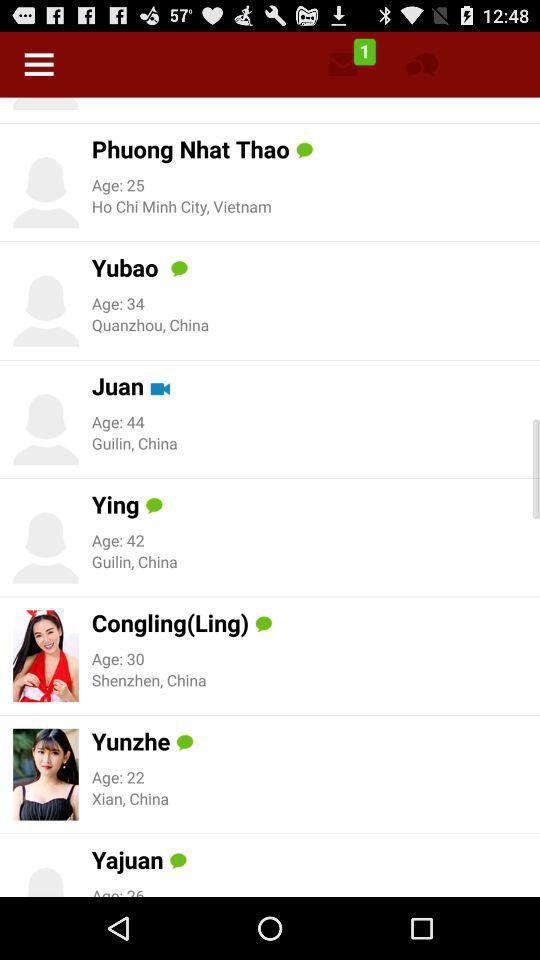Which user has maximum age?
When the provided information is insufficient, respond with <no answer>. <no answer> 